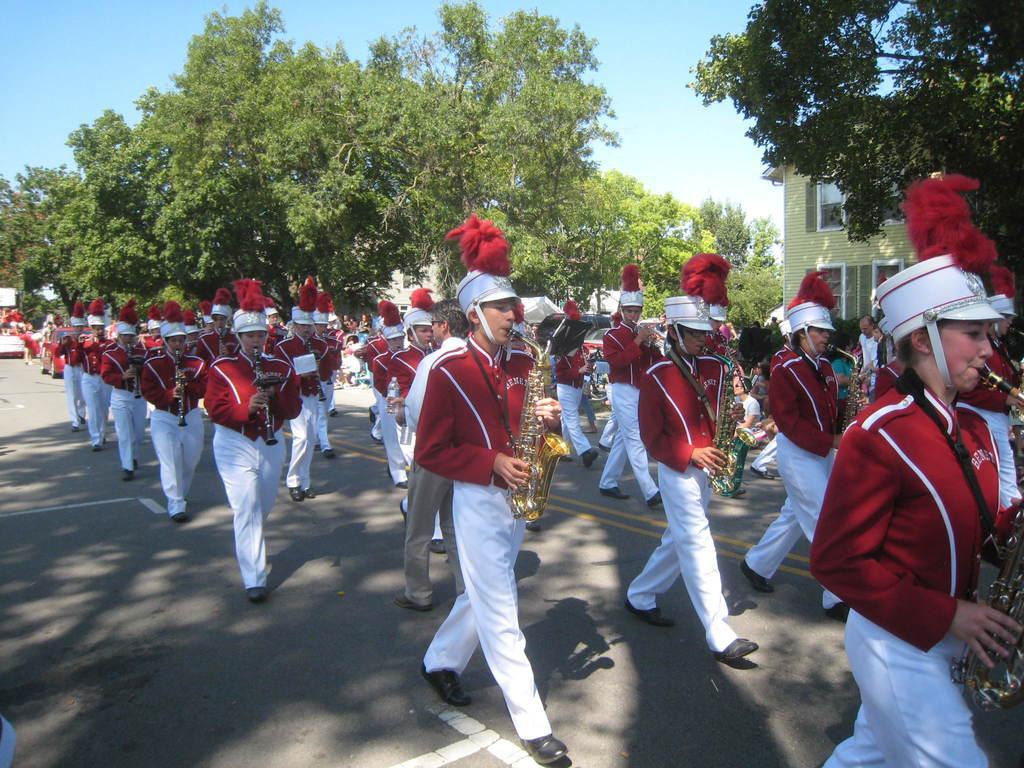In one or two sentences, can you explain what this image depicts? In this image, we can see people walking on the road and are wearing uniforms, caps and holding musical instruments and we can see some other people. In the background, there are trees and we can see buildings. At the top, there is sky. 